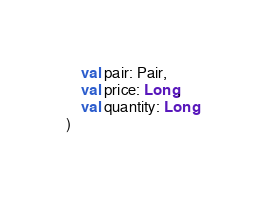Convert code to text. <code><loc_0><loc_0><loc_500><loc_500><_Kotlin_>    val pair: Pair,
    val price: Long,
    val quantity: Long
)</code> 